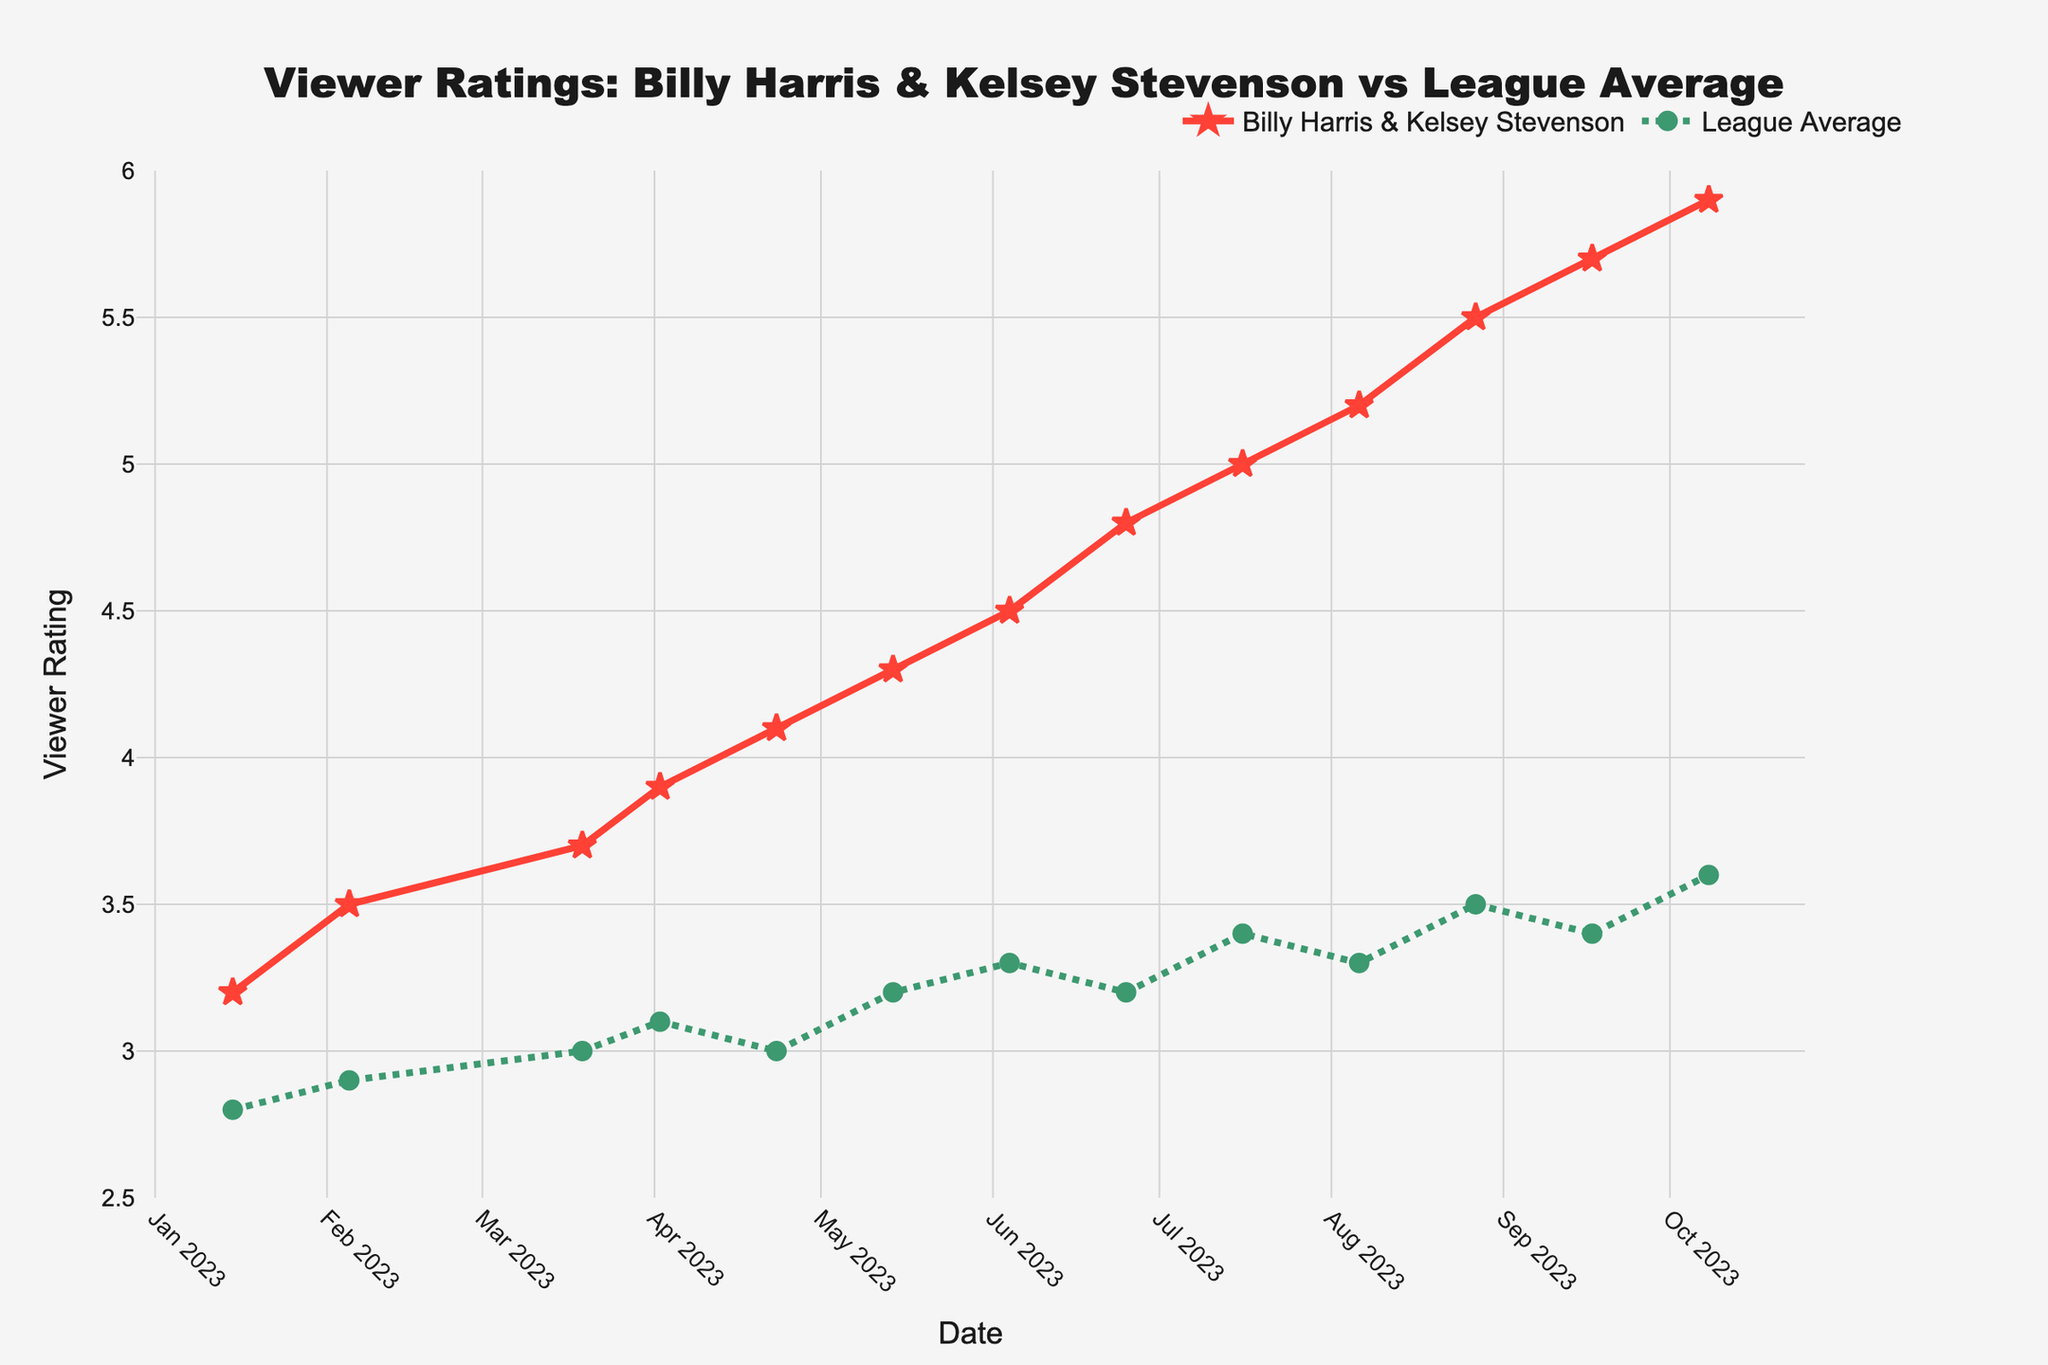What's the highest viewer rating achieved by Billy Harris & Kelsey Stevenson? To find the highest rating, look at the peak of the red line. The highest point is at 5.9 on 2023-10-08.
Answer: 5.9 How does the viewer rating for Billy Harris & Kelsey Stevenson in June 2023 compare to the league average for the same month? Locate June 2023 on the x-axis and compare the red and green lines. In June 2023, Billy Harris & Kelsey Stevenson had a rating of 4.5, while the league average was 3.3.
Answer: 4.5 vs. 3.3 What is the difference in viewer ratings between Billy Harris & Kelsey Stevenson and the league average on 2023-05-14? Find 2023-05-14 on the x-axis and check the values for both lines. Billy Harris & Kelsey Stevenson had 4.3, and the league average was 3.2. The difference is 4.3 - 3.2 = 1.1.
Answer: 1.1 What trend do you notice for viewer ratings of Billy Harris & Kelsey Stevenson from January to October 2023? Observe the red line from January to October. The viewer ratings consistently increase throughout this period, showing an upward trend.
Answer: Increasing How does the trend in viewer ratings for the league average compare to that of Billy Harris & Kelsey Stevenson throughout the year? Look at the lines for both sets of data. While Billy Harris & Kelsey Stevenson's rating shows a consistent and sharp increase, the league average fluctuates slightly but generally shows a modest upward trend.
Answer: Billy Harris & Kelsey Stevenson: Sharp increase; League Average: Modest increase In which month was the smallest gap between the viewer ratings of Billy Harris & Kelsey Stevenson and the league average? Examine the differences between the red and green lines for each month. The smallest gap appears to be in the earlier months, specifically in January 2023, where Billy Harris & Kelsey Stevenson have 3.2 and the league average is 2.8. The gap is 0.4.
Answer: January 2023 What was the viewer rating of Billy Harris & Kelsey Stevenson on 2023-04-23, and how did it deviate from the league average on the same day? Locate 2023-04-23 on the x-axis. Billy Harris & Kelsey Stevenson had a rating of 4.1, while the league average was 3.0. The deviation is 4.1 - 3.0 = 1.1.
Answer: 1.1 Calculate the average viewer rating for Billy Harris & Kelsey Stevenson over the entire period. Add up all the ratings: 3.2 + 3.5 + 3.7 + 3.9 + 4.1 + 4.3 + 4.5 + 4.8 + 5.0 + 5.2 + 5.5 + 5.7 + 5.9 = 57.3. There are 13 data points, so the average is 57.3 / 13 = 4.41.
Answer: 4.41 Which month showed the highest increase in viewer ratings for Billy Harris & Kelsey Stevenson compared to the previous month? Calculate the differences month-to-month. The largest increase is from June to July 2023, going from 4.8 to 5.0, an increase of 0.7.
Answer: July 2023 